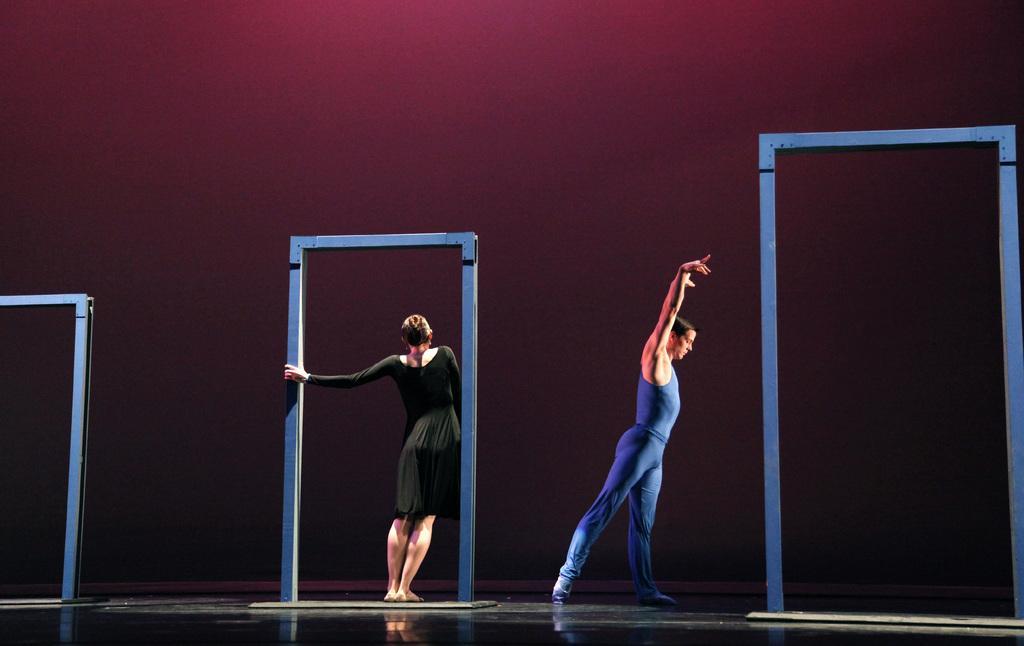In one or two sentences, can you explain what this image depicts? In this image we can see two people are dancing and also we can see some other objects, in the background, we can see the wall. 